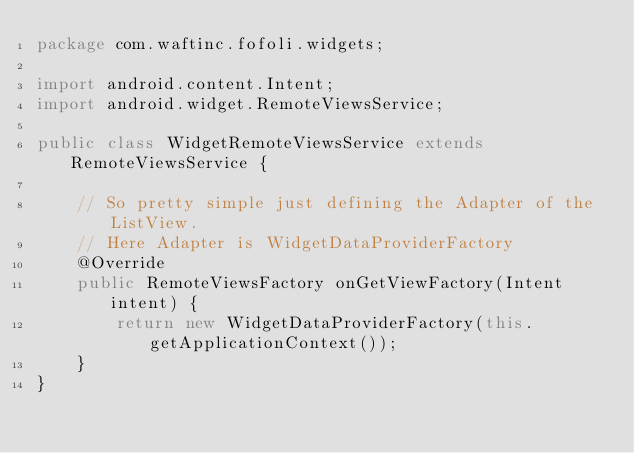Convert code to text. <code><loc_0><loc_0><loc_500><loc_500><_Java_>package com.waftinc.fofoli.widgets;

import android.content.Intent;
import android.widget.RemoteViewsService;

public class WidgetRemoteViewsService extends RemoteViewsService {

    // So pretty simple just defining the Adapter of the ListView.
    // Here Adapter is WidgetDataProviderFactory
    @Override
    public RemoteViewsFactory onGetViewFactory(Intent intent) {
        return new WidgetDataProviderFactory(this.getApplicationContext());
    }
}</code> 